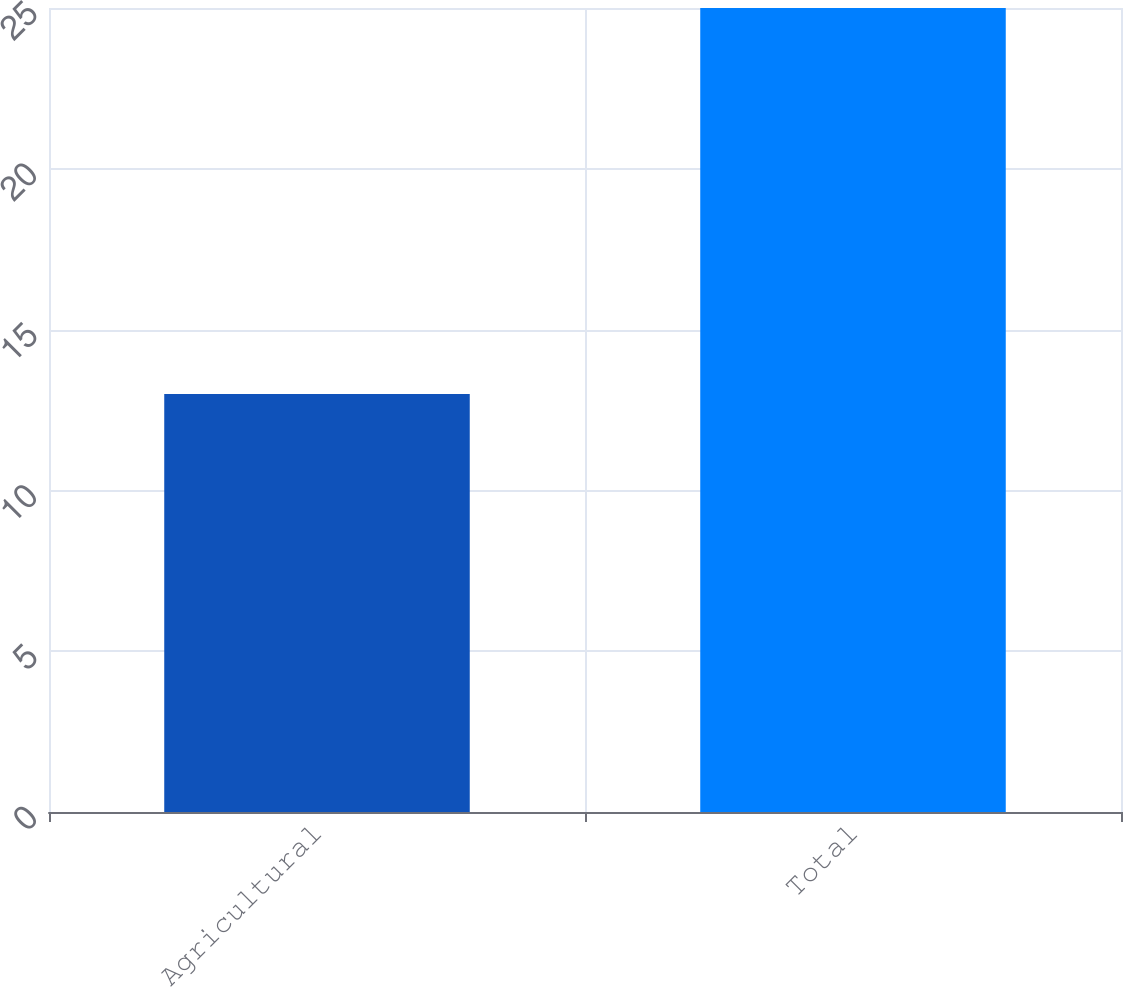Convert chart. <chart><loc_0><loc_0><loc_500><loc_500><bar_chart><fcel>Agricultural<fcel>Total<nl><fcel>13<fcel>25<nl></chart> 